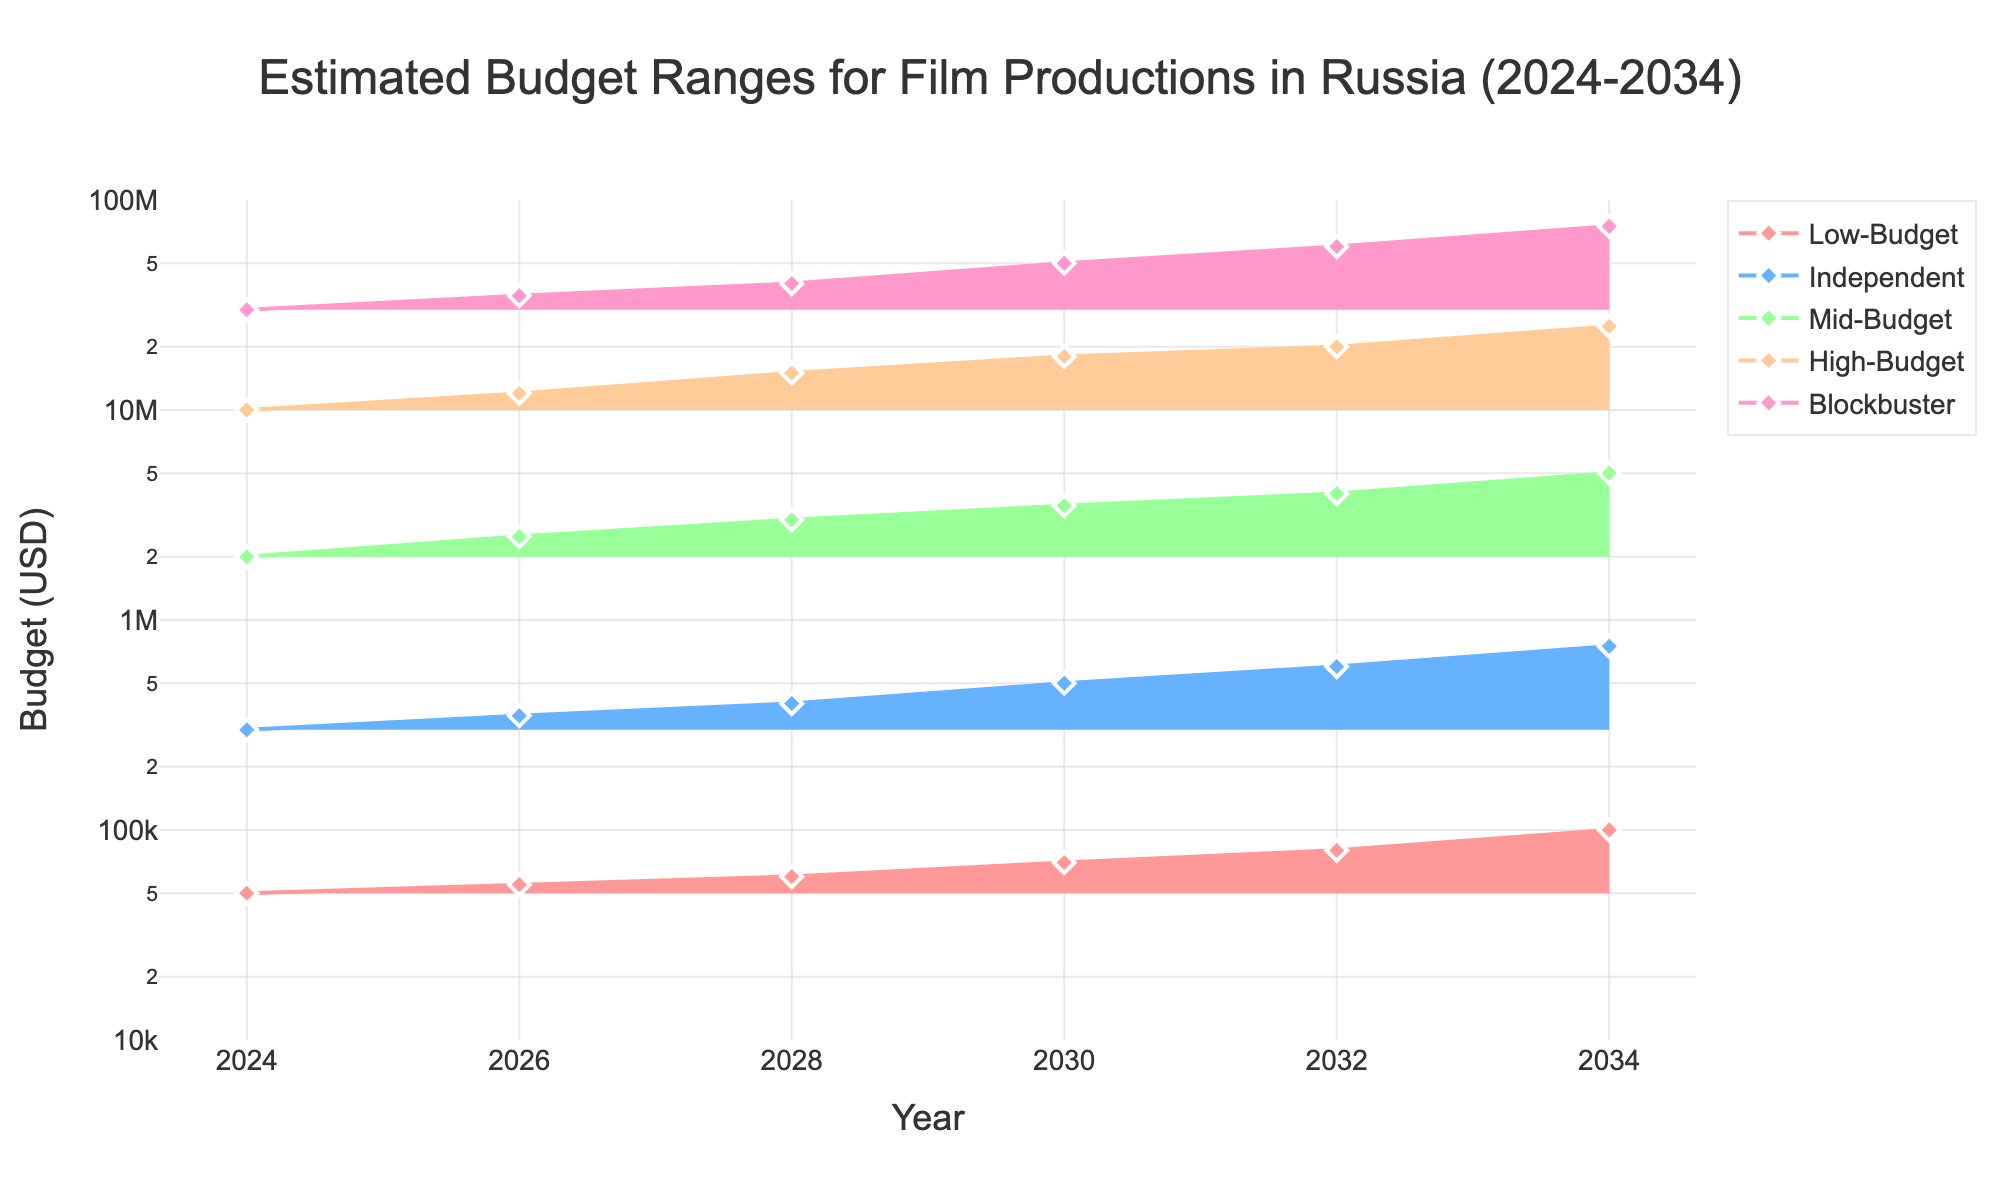What's the title of the figure? The title is found at the top of the figure. It provides a summary of the data represented.
Answer: Estimated Budget Ranges for Film Productions in Russia (2024-2034) How many types of film productions are represented in the figure? The figure uses different filled areas and markers for each type. By looking at the legend and the filled areas, you can count the distinct types.
Answer: Five Which type of film production has the highest estimated budget in 2034? Observe each trace at the year 2034. The one with the highest marker at 2034 is the category with the largest budget.
Answer: Blockbuster What is the estimated budget range for Mid-Budget films in 2024? Look for the markers along the 2024 x-axis and check the Mid-Budget category. Read the value directly from the plotted marker.
Answer: 2,000,000 USD How does the budget for Low-Budget films change from 2024 to 2034? Locate the values for Low-Budget films at 2024 and 2034. Subtract the 2024 budget from the 2034 budget to find the difference.
Answer: It increases by 50,000 USD Which film category has the steepest increase in budget from 2024 to 2034? Calculate the difference between 2034 and 2024 values for each category. The largest difference indicates the steepest increase.
Answer: Blockbuster Are the budgets for Independent films and Mid-Budget films closer in 2024 or 2034? Compare the differences between Independent and Mid-Budget films for both years. The year with the smaller difference indicates closer budgets.
Answer: 2034 What is the average estimated budget in 2032 for High-Budget and Blockbuster films combined? Add the budgets for both categories in 2032, then divide by 2 to find the average.
Answer: 40,000,000 USD Which production category has the most consistent budget growth over the years? Look at the trend lines for each category. The one with the smoothest, most linear increase shows the most consistency.
Answer: Low-Budget What is the ratio of the budget for Blockbuster films to Low-Budget films in the year 2030? Divide the Blockbuster budget by the Low-Budget budget for 2030. This ratio shows the relative size.
Answer: 714.3 